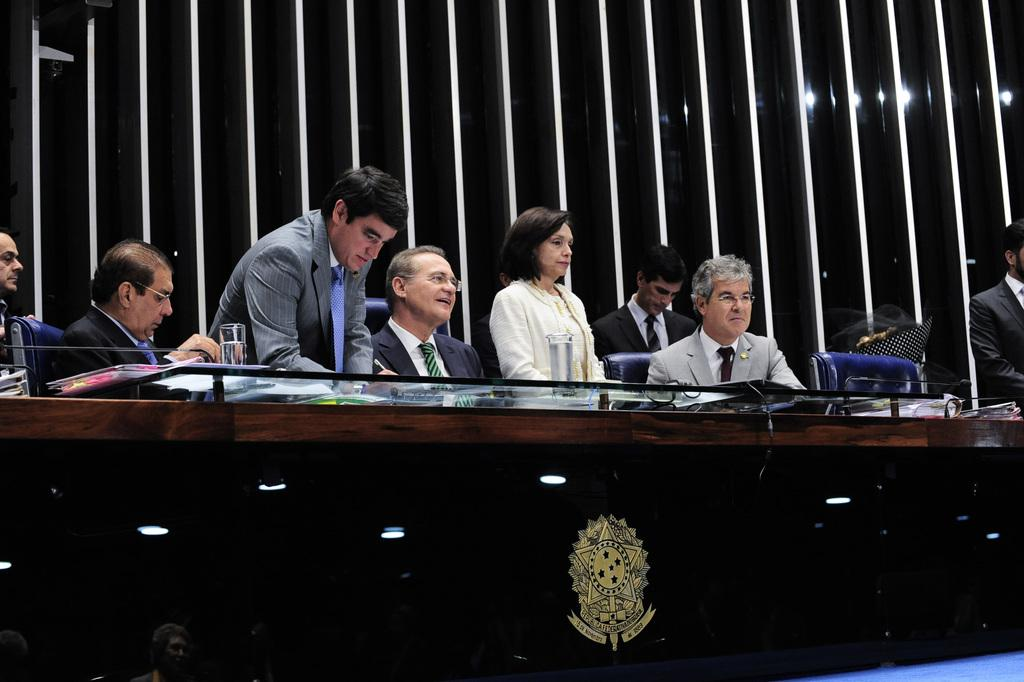Who or what can be seen in the image? There are people in the image. What are the people doing in the image? The people are sitting in chairs. What type of rice is being served to the horses in the image? There are no horses or rice present in the image; it only features people sitting in chairs. 